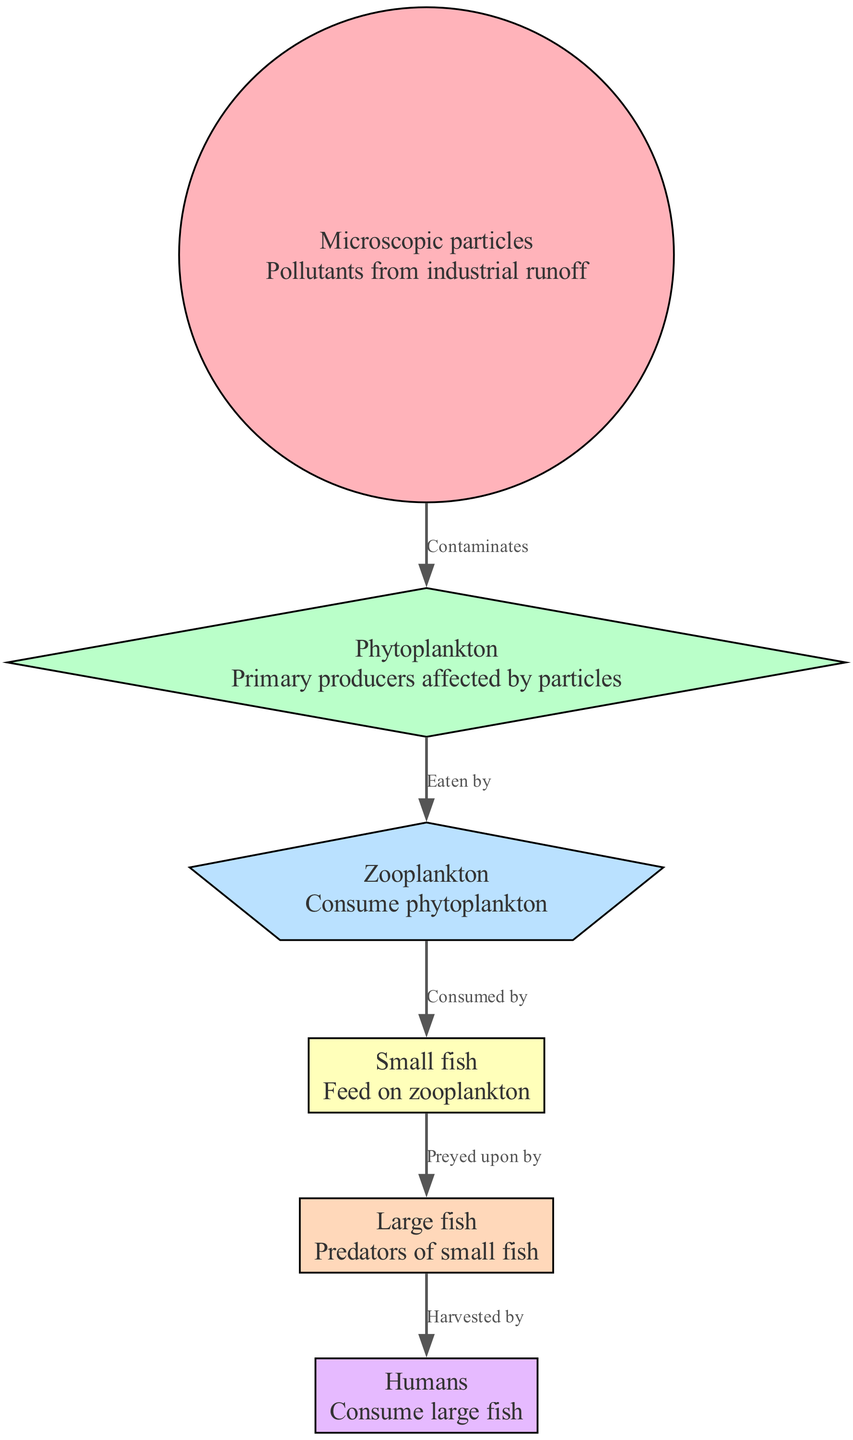What is the first node in the food chain? The diagram starts with "Microscopic particles," indicating that it is the first node of the food chain.
Answer: Microscopic particles How many nodes are there in total? Counting from the diagram, there are six distinct nodes represented.
Answer: 6 What relationship is there between "Phytoplankton" and "Zooplankton"? The diagram indicates that "Zooplankton" is "Eaten by" "Phytoplankton," signifying that there is a direct consumption relationship.
Answer: Eaten by Which node is associated with human consumption? The final node in the diagram is "Humans," which represents the endpoint where large fish are harvested and consumed.
Answer: Humans What do "Small fish" feed on? The relationship defined in the diagram shows that "Small fish" "Feed on" "Zooplankton" in the food chain.
Answer: Zooplankton If "Microscopic particles" increase, which node is likely to be affected directly? "Microscopic particles" "Contaminates" "Phytoplankton," directly indicating that its increase would adversely affect phytoplankton.
Answer: Phytoplankton What is the relationship between "Large fish" and "Humans"? According to the diagram, "Humans" "Harvest" "Large fish," indicating that humans depend on large fish as a food source.
Answer: Harvested by Which category of organisms acts as primary producers? The diagram shows that "Phytoplankton" is designated as the primary producers, meaning they produce energy through photosynthesis.
Answer: Phytoplankton What is the effect of particle pollution on the food chain? "Microscopic particles" at the top of the food chain disrupt the flow of energy, starting with "Phytoplankton" being contaminated, thus cascading through the chain.
Answer: Disruption 